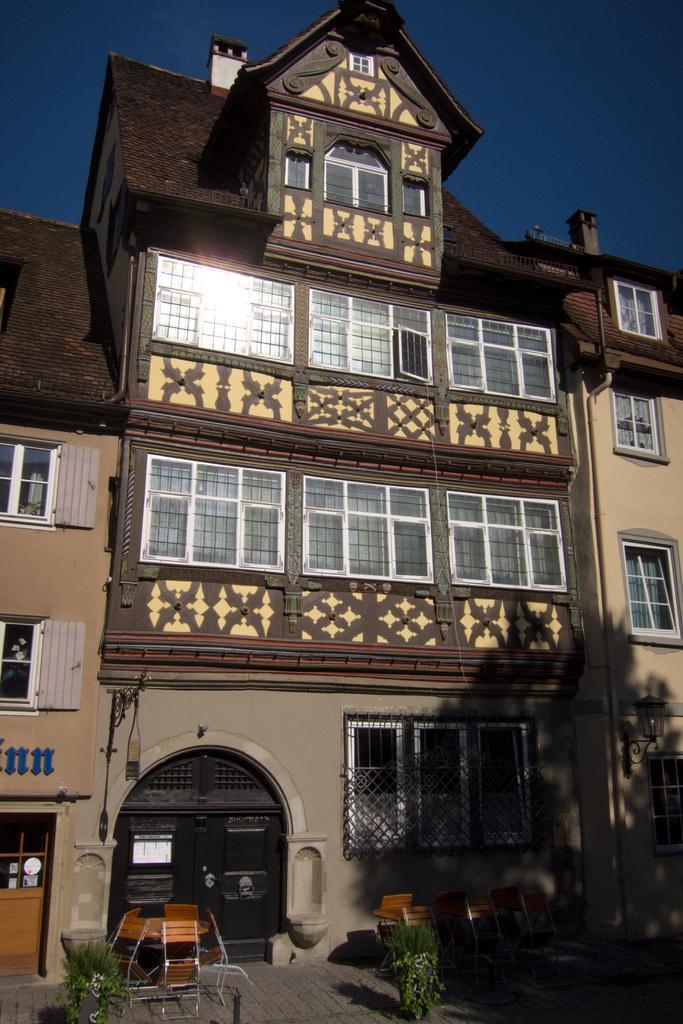Describe this image in one or two sentences. In this image we can see few buildings and they are having few windows. We can see the reflection of sunlight on the window glass in the image. There are few chairs on the ground. There are few plants in the image. 